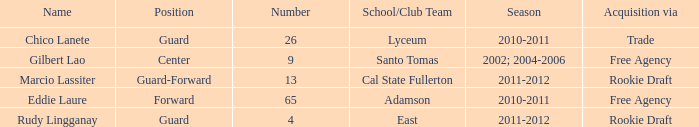What season did marcio lassiter experience? 2011-2012. Can you parse all the data within this table? {'header': ['Name', 'Position', 'Number', 'School/Club Team', 'Season', 'Acquisition via'], 'rows': [['Chico Lanete', 'Guard', '26', 'Lyceum', '2010-2011', 'Trade'], ['Gilbert Lao', 'Center', '9', 'Santo Tomas', '2002; 2004-2006', 'Free Agency'], ['Marcio Lassiter', 'Guard-Forward', '13', 'Cal State Fullerton', '2011-2012', 'Rookie Draft'], ['Eddie Laure', 'Forward', '65', 'Adamson', '2010-2011', 'Free Agency'], ['Rudy Lingganay', 'Guard', '4', 'East', '2011-2012', 'Rookie Draft']]} 